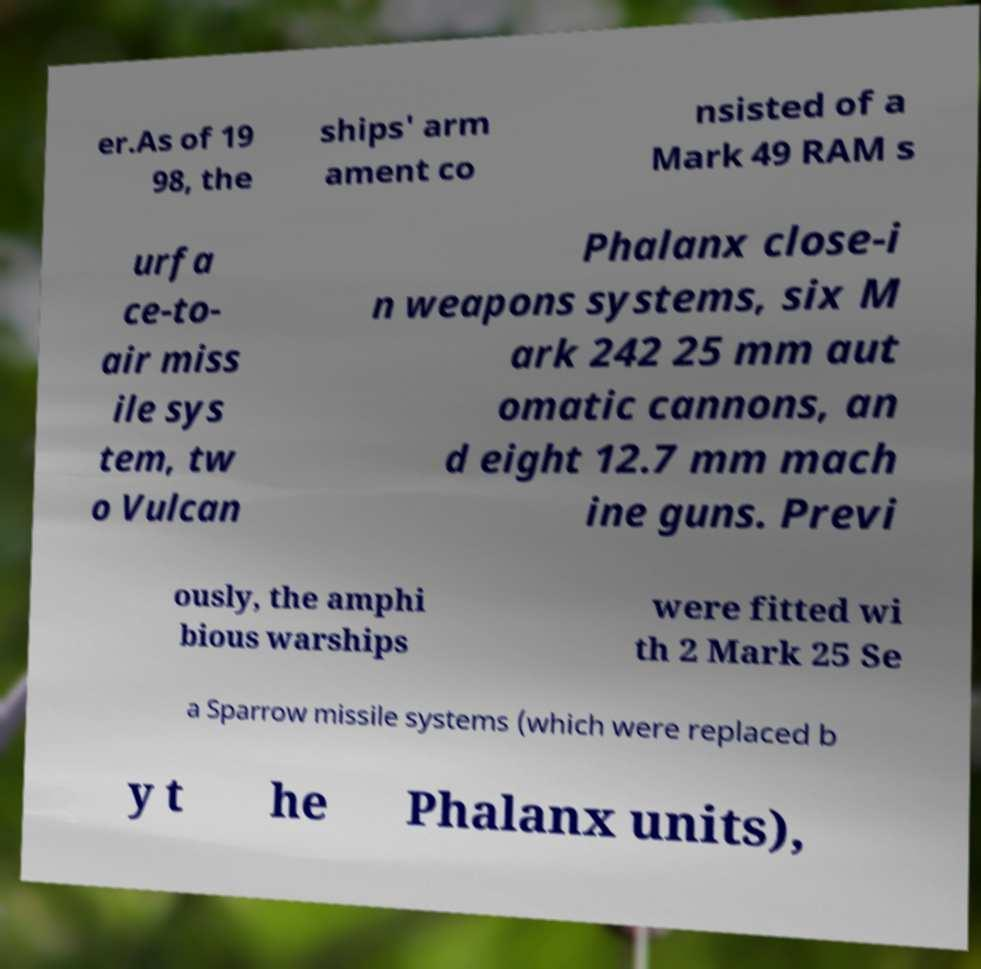Could you assist in decoding the text presented in this image and type it out clearly? er.As of 19 98, the ships' arm ament co nsisted of a Mark 49 RAM s urfa ce-to- air miss ile sys tem, tw o Vulcan Phalanx close-i n weapons systems, six M ark 242 25 mm aut omatic cannons, an d eight 12.7 mm mach ine guns. Previ ously, the amphi bious warships were fitted wi th 2 Mark 25 Se a Sparrow missile systems (which were replaced b y t he Phalanx units), 